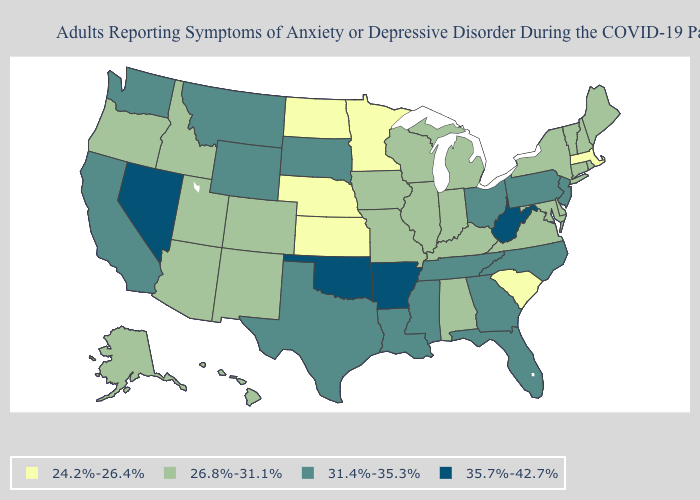Name the states that have a value in the range 35.7%-42.7%?
Concise answer only. Arkansas, Nevada, Oklahoma, West Virginia. What is the value of Connecticut?
Write a very short answer. 26.8%-31.1%. Is the legend a continuous bar?
Short answer required. No. Does Iowa have the highest value in the USA?
Quick response, please. No. Name the states that have a value in the range 24.2%-26.4%?
Write a very short answer. Kansas, Massachusetts, Minnesota, Nebraska, North Dakota, South Carolina. Which states have the highest value in the USA?
Be succinct. Arkansas, Nevada, Oklahoma, West Virginia. What is the value of Montana?
Answer briefly. 31.4%-35.3%. Name the states that have a value in the range 35.7%-42.7%?
Be succinct. Arkansas, Nevada, Oklahoma, West Virginia. Among the states that border Delaware , does Maryland have the highest value?
Keep it brief. No. Does Ohio have the lowest value in the MidWest?
Quick response, please. No. Which states have the highest value in the USA?
Be succinct. Arkansas, Nevada, Oklahoma, West Virginia. Among the states that border Wisconsin , which have the lowest value?
Answer briefly. Minnesota. Which states have the highest value in the USA?
Keep it brief. Arkansas, Nevada, Oklahoma, West Virginia. Does Nevada have the highest value in the USA?
Be succinct. Yes. 